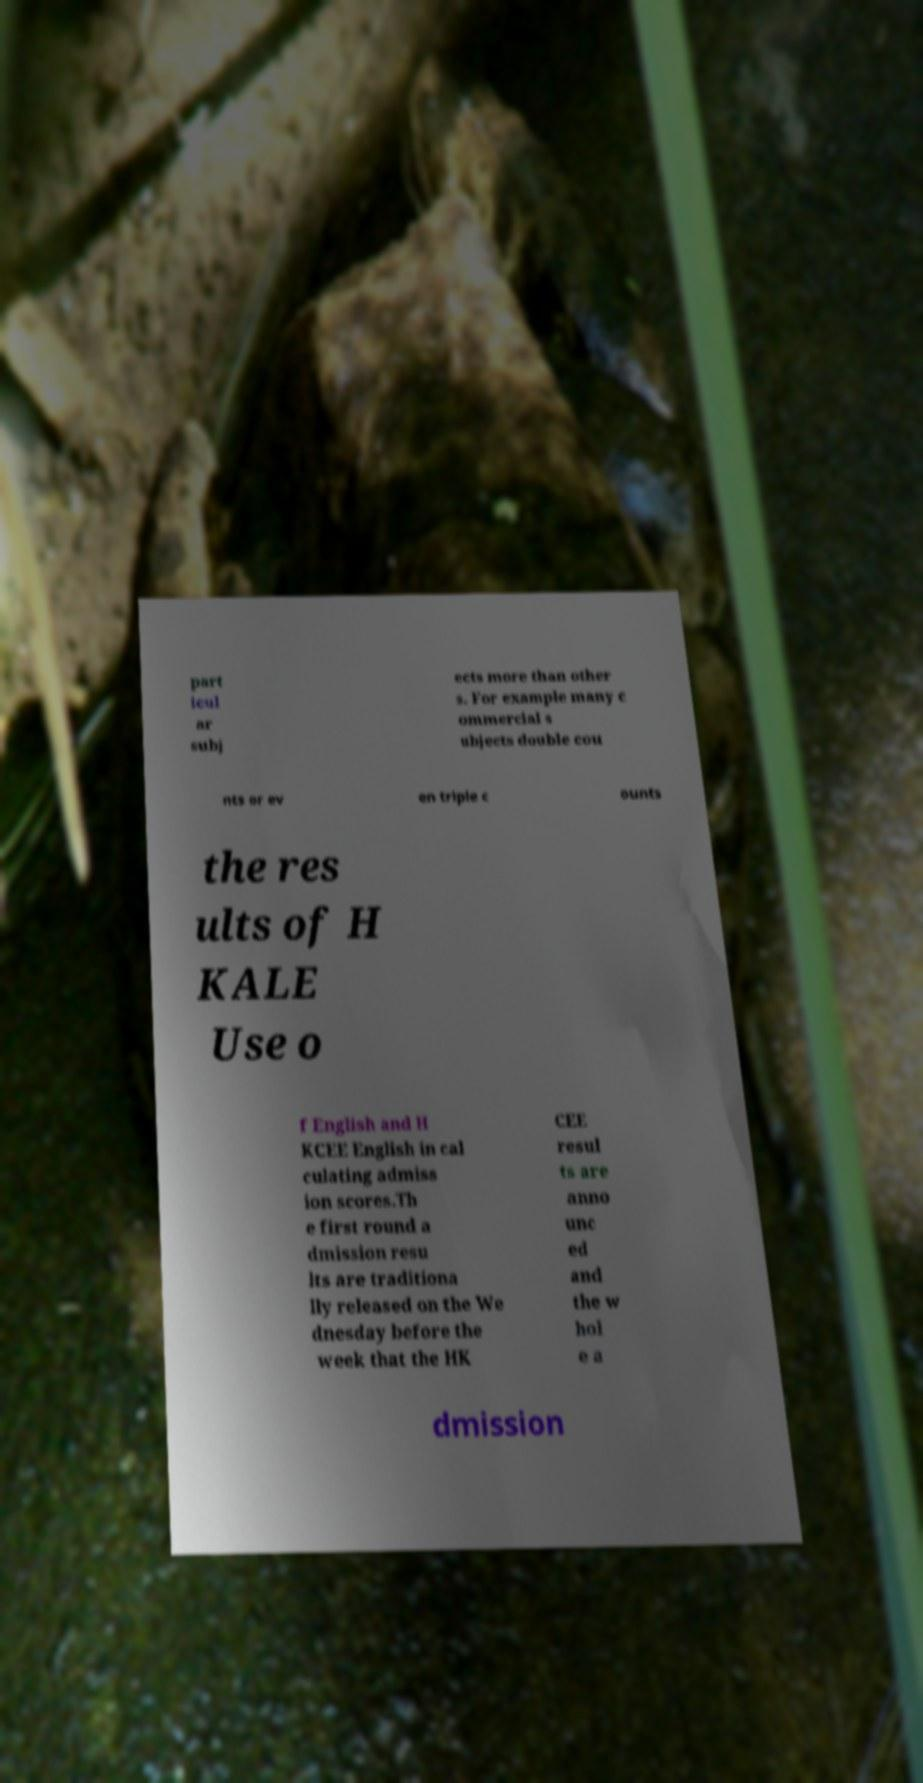For documentation purposes, I need the text within this image transcribed. Could you provide that? part icul ar subj ects more than other s. For example many c ommercial s ubjects double cou nts or ev en triple c ounts the res ults of H KALE Use o f English and H KCEE English in cal culating admiss ion scores.Th e first round a dmission resu lts are traditiona lly released on the We dnesday before the week that the HK CEE resul ts are anno unc ed and the w hol e a dmission 